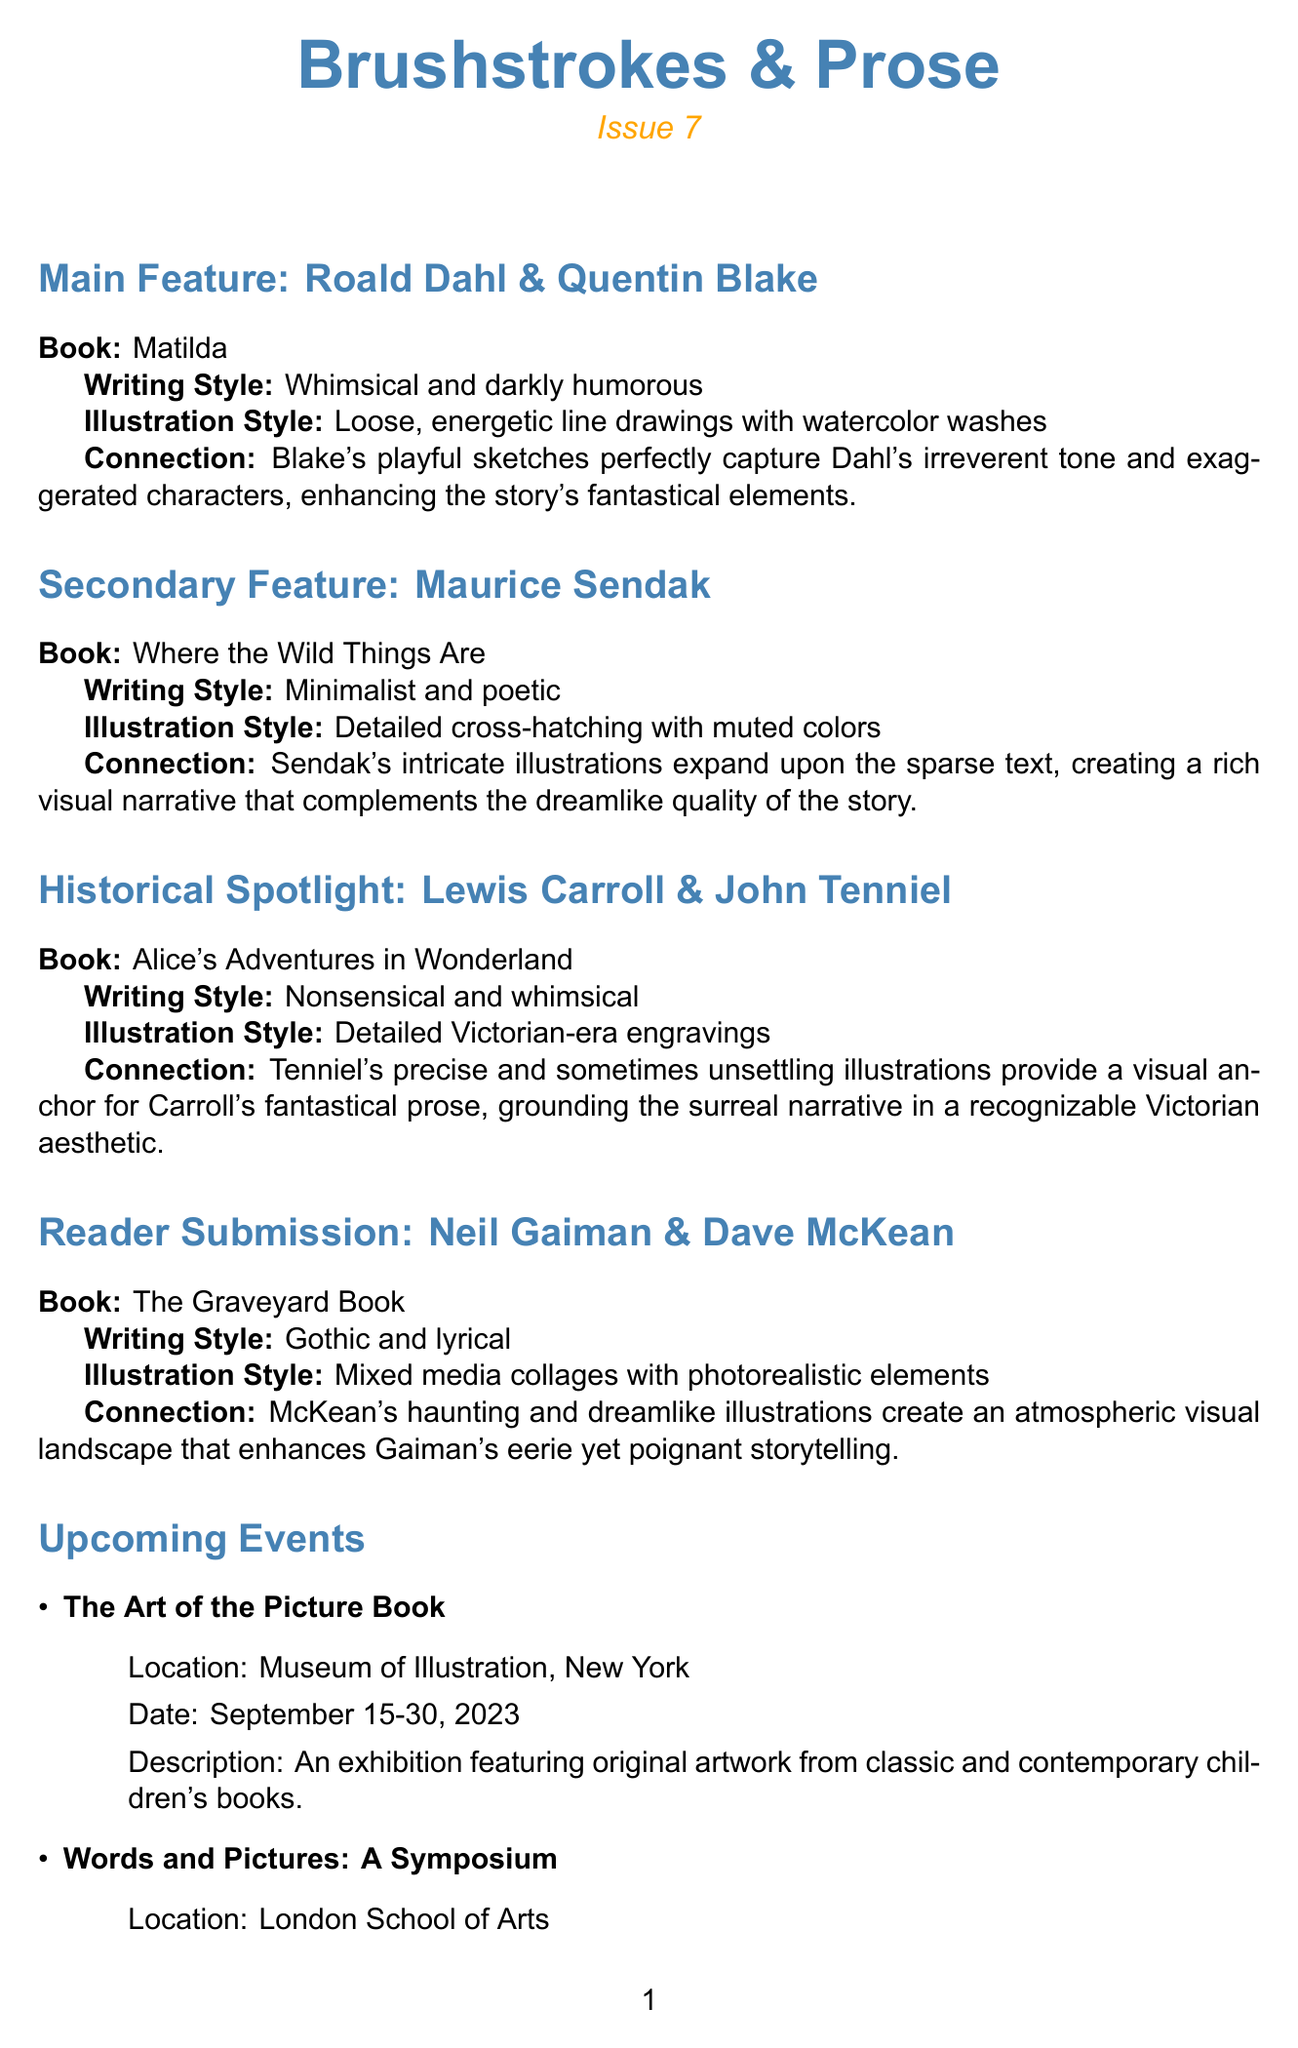What is the newsletter name? The newsletter is titled "Brushstrokes & Prose" as stated in the document.
Answer: Brushstrokes & Prose Who is the illustrator of "Matilda"? The document indicates that Quentin Blake is the illustrator for "Matilda".
Answer: Quentin Blake What is the date of the "Words and Pictures: A Symposium"? The document specifies that the event occurs on October 5-6, 2023.
Answer: October 5-6, 2023 Which author is highlighted in the historical spotlight section? The historical spotlight focuses on Lewis Carroll as per the document.
Answer: Lewis Carroll How do Quentin Blake's illustrations relate to Roald Dahl's writing in "Matilda"? The analysis states that Blake's sketches capture Dahl's tone, enhancing the story's elements.
Answer: Enhancing the story's fantastical elements What style of illustrations does Neil Gaiman's "The Graveyard Book" feature? The document describes the illustration style as mixed media collages with photorealistic elements.
Answer: Mixed media collages with photorealistic elements What is the theme of the reader challenge? The challenge encourages readers to imagine contrasting illustrations for their favorite book.
Answer: Style Swap How many main features are discussed in the newsletter? The document outlines one main feature regarding Roald Dahl and Quentin Blake.
Answer: One main feature 